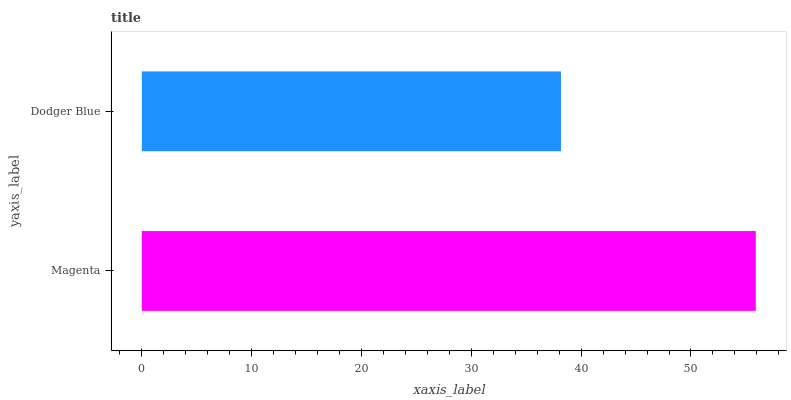Is Dodger Blue the minimum?
Answer yes or no. Yes. Is Magenta the maximum?
Answer yes or no. Yes. Is Dodger Blue the maximum?
Answer yes or no. No. Is Magenta greater than Dodger Blue?
Answer yes or no. Yes. Is Dodger Blue less than Magenta?
Answer yes or no. Yes. Is Dodger Blue greater than Magenta?
Answer yes or no. No. Is Magenta less than Dodger Blue?
Answer yes or no. No. Is Magenta the high median?
Answer yes or no. Yes. Is Dodger Blue the low median?
Answer yes or no. Yes. Is Dodger Blue the high median?
Answer yes or no. No. Is Magenta the low median?
Answer yes or no. No. 